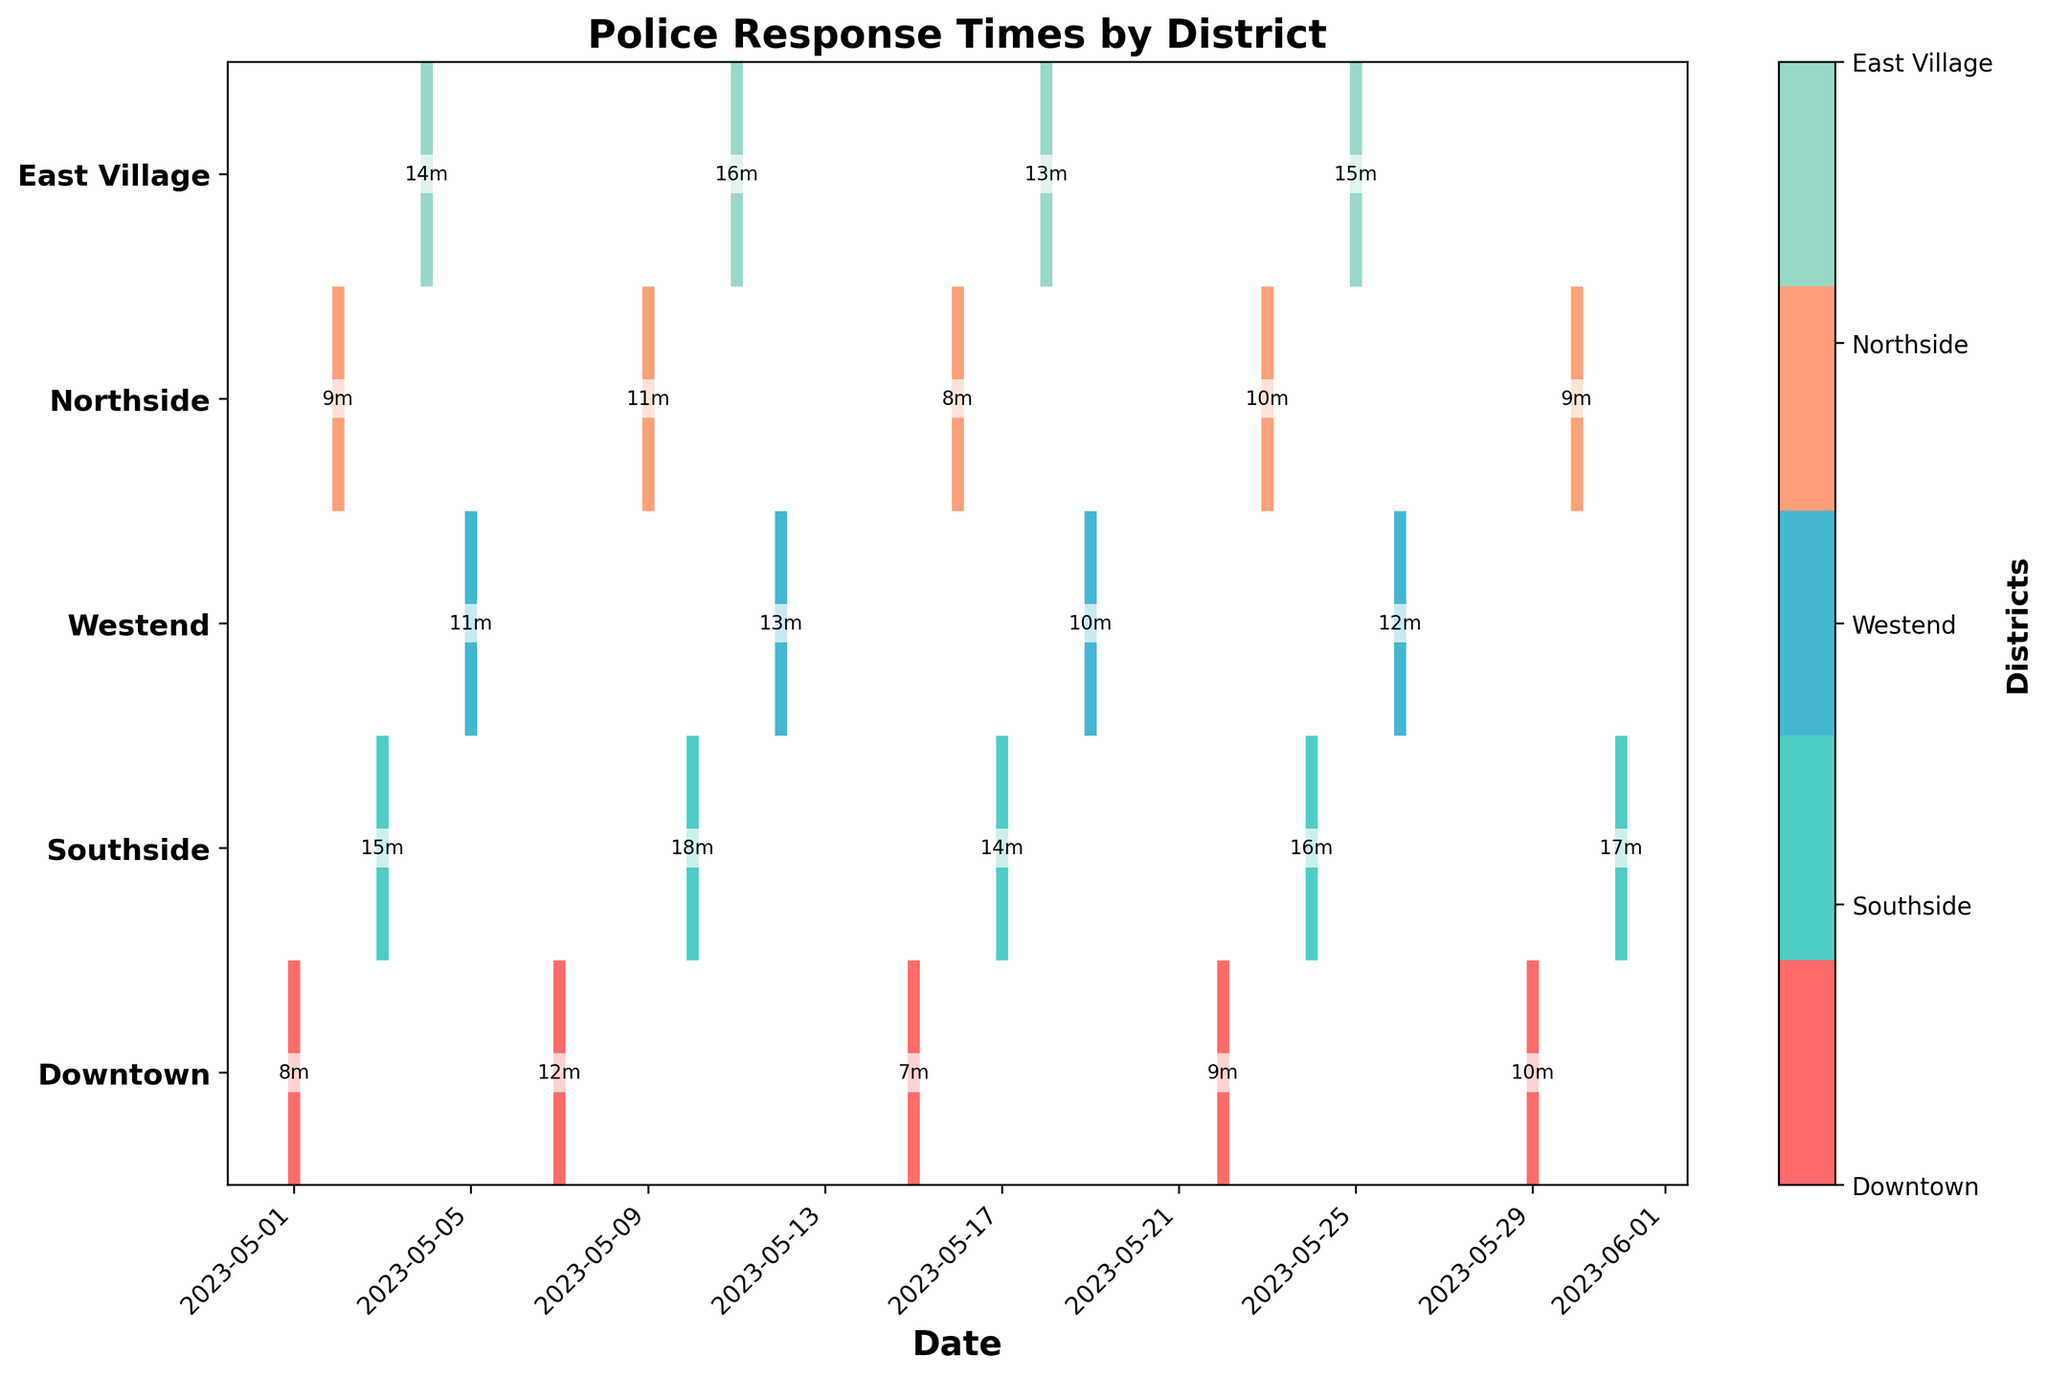What is the title of the plot? The title is located at the top of the plot and provides an overview of the data presented. In this case, the title reads "Police Response Times by District".
Answer: Police Response Times by District Which district has the fastest police response time? By observing the plots and annotations, the fastest response time is 7 minutes, which occurs in the Downtown district on May 15.
Answer: Downtown How many distinct districts are represented in the plot? You can count the labels on the y-axis. The unique district labels provide the number of different districts represented. There are five districts: Downtown, Southside, Westend, Northside, and East Village.
Answer: Five Which date had the slowest police response time in Southside? By looking at the event points for Southside, the slowest response time (18 minutes) is annotated on May 10.
Answer: May 10 What is the average response time in the Northside district? The Northside has response times of 9, 11, 8, 10, and 9 minutes. The average is calculated by summing these times (9 + 11 + 8 + 10 + 9 = 47) and dividing by the number of data points, which is 5. Thus, the average response time is 47/5 = 9.4 minutes.
Answer: 9.4 minutes Compare the average response times between Southside and Westend. Which is higher? The Southside has response times of 15, 18, 14, 16, and 17 minutes. The average is (15 + 18 + 14 + 16 + 17 = 80) / 5 = 16 minutes. The Westend has response times of 11, 13, 10, and 12 minutes. The average is (11 + 13 + 10 + 12 = 46) / 4 = 11.5 minutes. Comparing these, the average response time in Southside (16) is higher than in Westend (11.5).
Answer: Southside On which dates does the Downtown district not have the fastest response time among all districts? By comparing the response times on corresponding dates, the Downtown district does not have the fastest response times on May 1 (8 vs. 7), May 7 (12 vs. 7), May 22 (9 vs. 8), and May 29 (10 vs. 9).
Answer: May 1, May 7, May 22, May 29 Are there any dates when multiple districts had the same response time? From the annotations, you can see that on May 26, both Westend and Northside had response times of 10 minutes.
Answer: May 26 Which district shows the most stable response times (least variation)? Variation can be visually assessed by looking at the spread of the plot points. The Downtown district has response times close to each other, ranging from 7 to 12 minutes. In contrast, other districts have broader spreads (e.g., Southside ranges from 14 to 18 minutes). Downtown shows the least variation in response times.
Answer: Downtown 